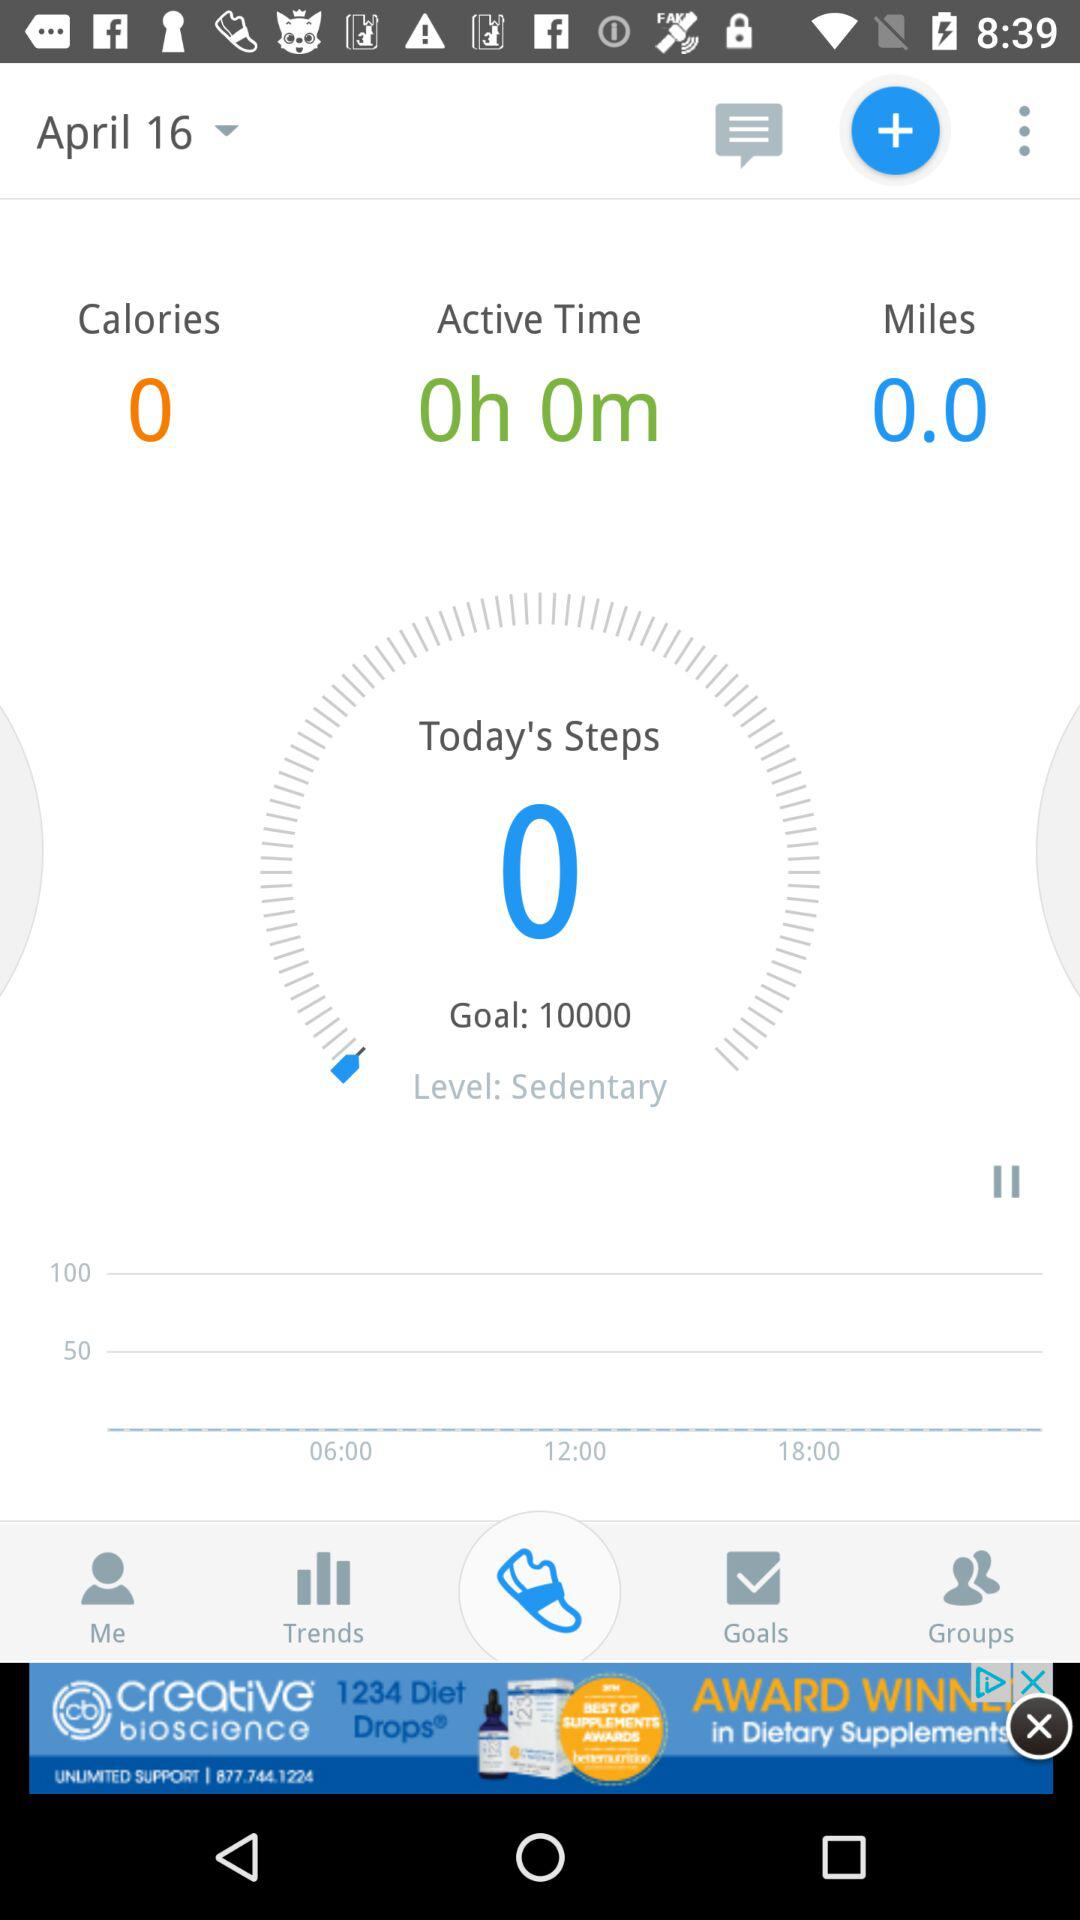How many steps are taken today? The number of steps taken today is 0. 